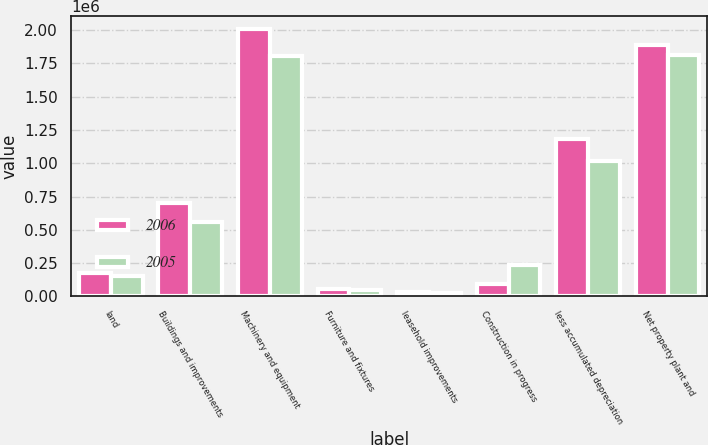<chart> <loc_0><loc_0><loc_500><loc_500><stacked_bar_chart><ecel><fcel>land<fcel>Buildings and improvements<fcel>Machinery and equipment<fcel>Furniture and fixtures<fcel>leasehold improvements<fcel>Construction in progress<fcel>less accumulated depreciation<fcel>Net property plant and<nl><fcel>2006<fcel>178553<fcel>698878<fcel>2.00685e+06<fcel>53961<fcel>33702<fcel>96579<fcel>1.18043e+06<fcel>1.88809e+06<nl><fcel>2005<fcel>155670<fcel>559723<fcel>1.80237e+06<fcel>44765<fcel>28784<fcel>233525<fcel>1.01411e+06<fcel>1.81073e+06<nl></chart> 